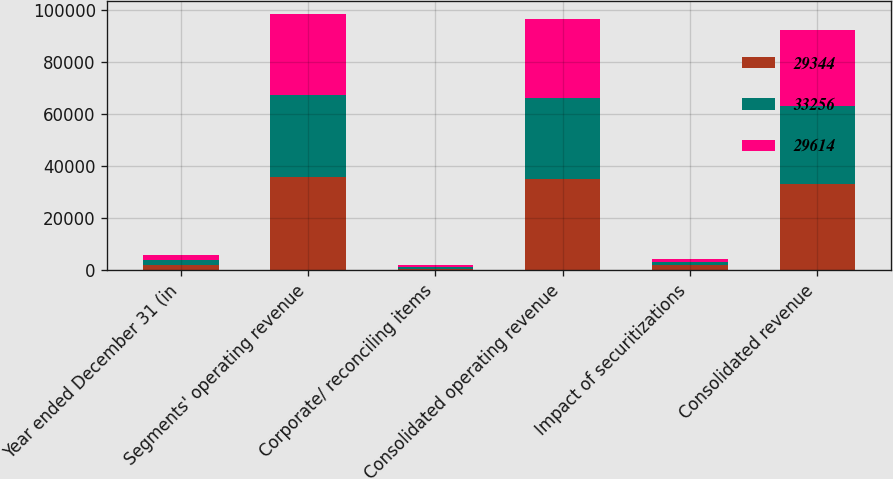Convert chart to OTSL. <chart><loc_0><loc_0><loc_500><loc_500><stacked_bar_chart><ecel><fcel>Year ended December 31 (in<fcel>Segments' operating revenue<fcel>Corporate/ reconciling items<fcel>Consolidated operating revenue<fcel>Impact of securitizations<fcel>Consolidated revenue<nl><fcel>29344<fcel>2003<fcel>35752<fcel>626<fcel>35126<fcel>1870<fcel>33256<nl><fcel>33256<fcel>2002<fcel>31679<fcel>626<fcel>31053<fcel>1439<fcel>29614<nl><fcel>29614<fcel>2001<fcel>31103<fcel>711<fcel>30392<fcel>1048<fcel>29344<nl></chart> 